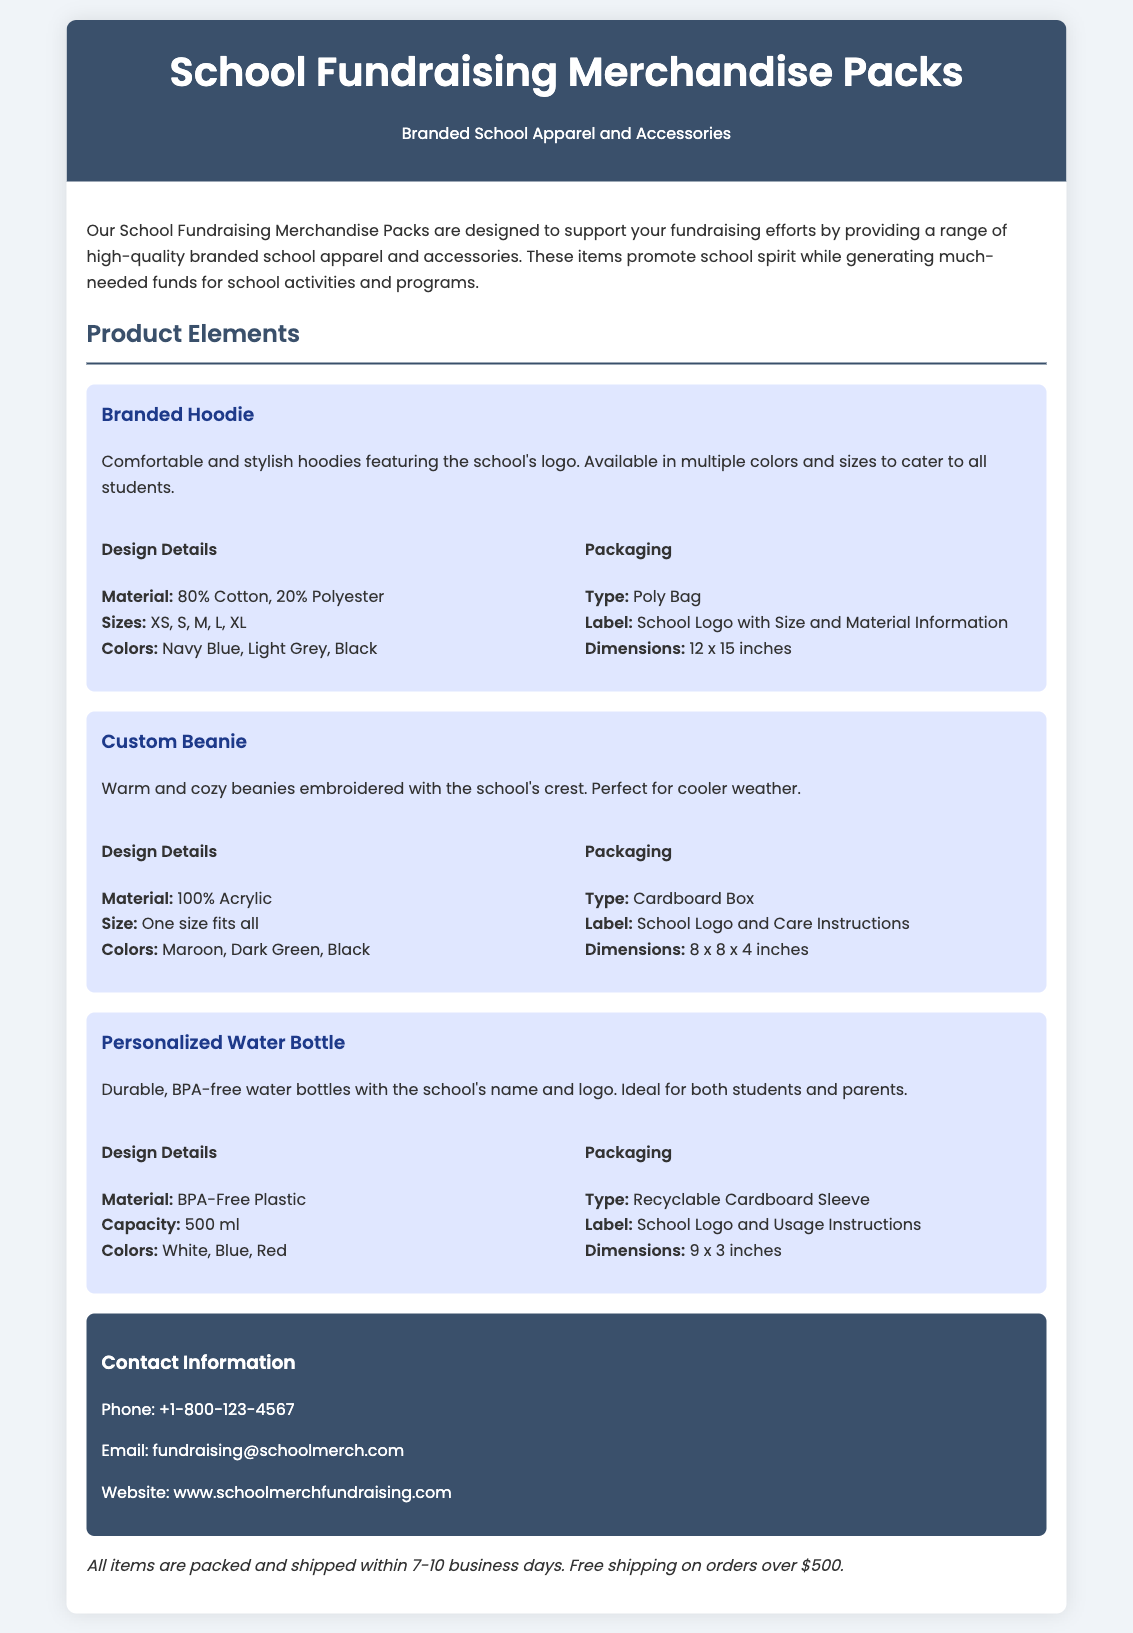What types of merchandise are included in the packs? The document lists three types of merchandise: Branded Hoodie, Custom Beanie, and Personalized Water Bottle.
Answer: Branded Hoodie, Custom Beanie, Personalized Water Bottle What is the material of the Branded Hoodie? The material of the Branded Hoodie is detailed in the design section, which states it is 80% Cotton and 20% Polyester.
Answer: 80% Cotton, 20% Polyester What is the packaging type for the Custom Beanie? The packaging type for the Custom Beanie is specified in the packaging section, stating it is a Cardboard Box.
Answer: Cardboard Box How long does it take for items to be packed and shipped? The shipping information specifies that all items are packed and shipped within 7-10 business days.
Answer: 7-10 business days What color options are available for the Personalized Water Bottle? The color options are listed in the design details for the Personalized Water Bottle, which includes White, Blue, and Red.
Answer: White, Blue, Red What is the size of the Branded Hoodie? The design details mention the available sizes for the Branded Hoodie, which are XS, S, M, L, and XL.
Answer: XS, S, M, L, XL What is the label for the packaging of the Personalized Water Bottle? The label information for the Personalized Water Bottle is included in the packaging section, noting School Logo and Usage Instructions.
Answer: School Logo and Usage Instructions What colors are available for the Custom Beanie? The design details for the Custom Beanie specify the available colors, which include Maroon, Dark Green, and Black.
Answer: Maroon, Dark Green, Black 